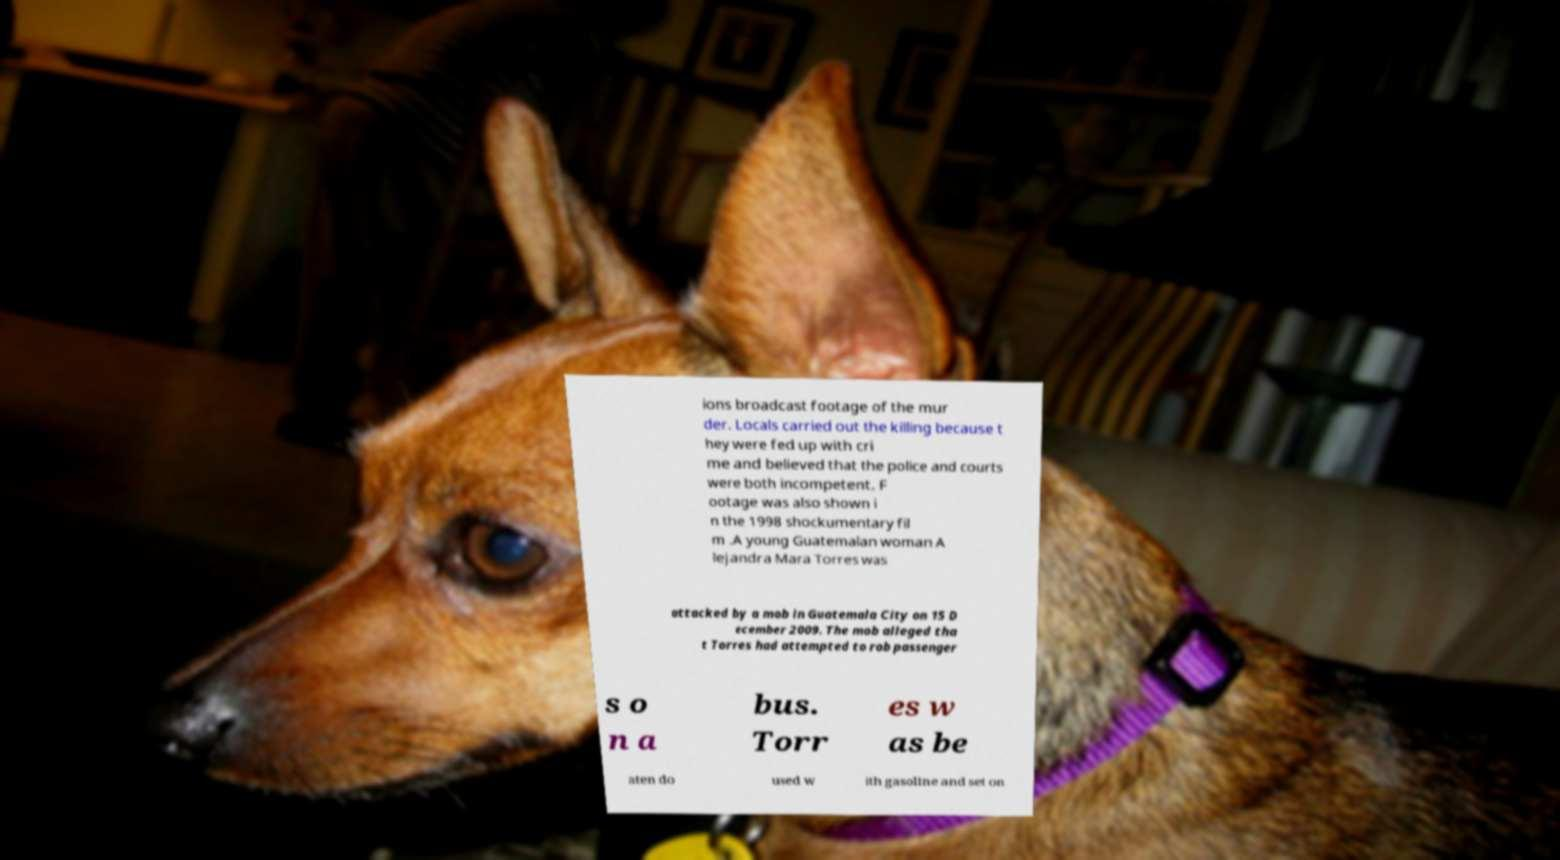Could you extract and type out the text from this image? ions broadcast footage of the mur der. Locals carried out the killing because t hey were fed up with cri me and believed that the police and courts were both incompetent. F ootage was also shown i n the 1998 shockumentary fil m .A young Guatemalan woman A lejandra Mara Torres was attacked by a mob in Guatemala City on 15 D ecember 2009. The mob alleged tha t Torres had attempted to rob passenger s o n a bus. Torr es w as be aten do used w ith gasoline and set on 